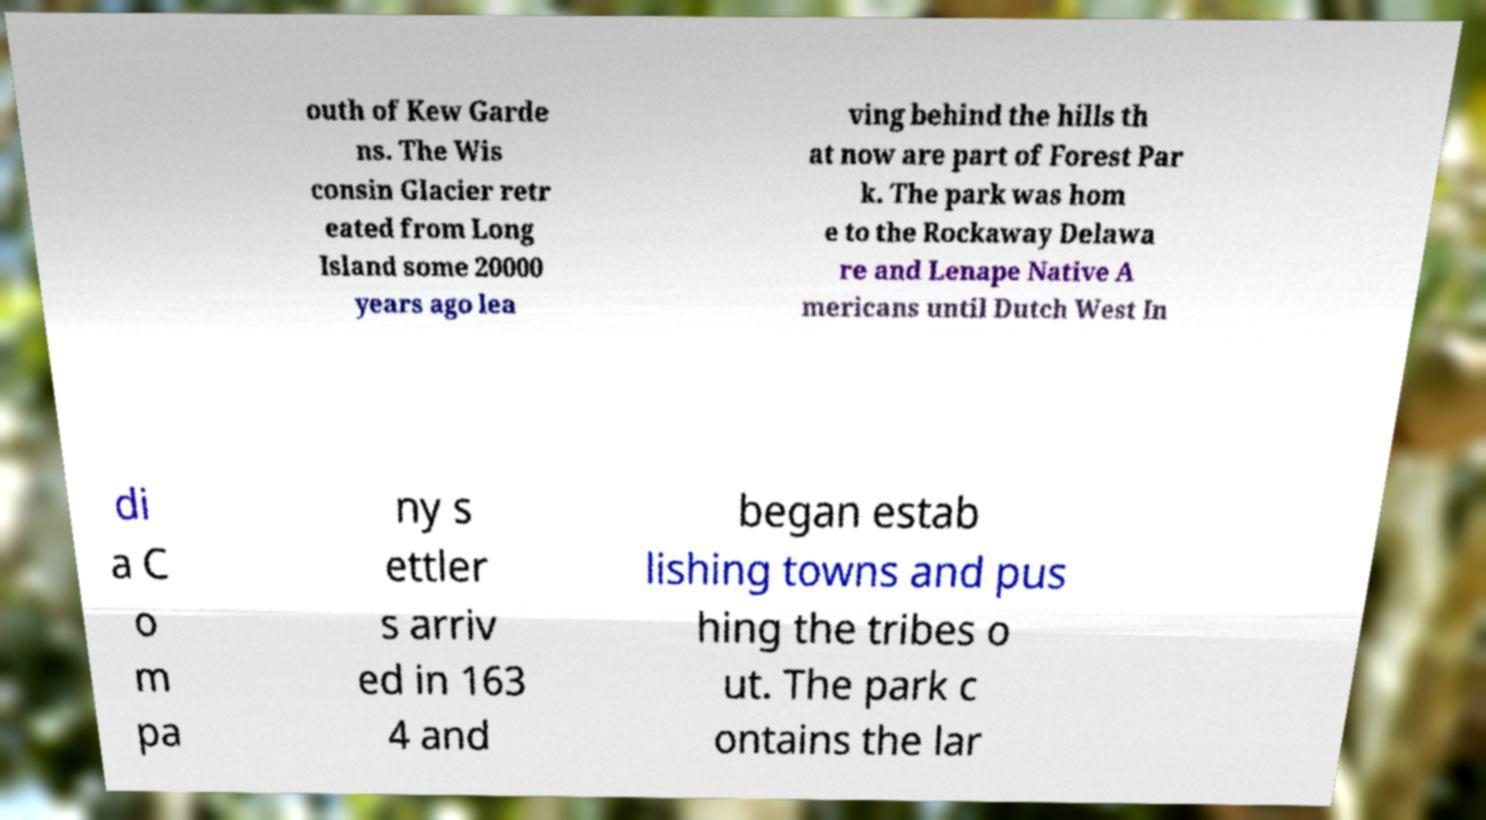What messages or text are displayed in this image? I need them in a readable, typed format. outh of Kew Garde ns. The Wis consin Glacier retr eated from Long Island some 20000 years ago lea ving behind the hills th at now are part of Forest Par k. The park was hom e to the Rockaway Delawa re and Lenape Native A mericans until Dutch West In di a C o m pa ny s ettler s arriv ed in 163 4 and began estab lishing towns and pus hing the tribes o ut. The park c ontains the lar 